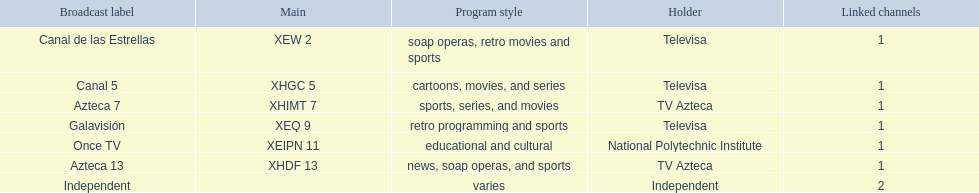What are each of the networks? Canal de las Estrellas, Canal 5, Azteca 7, Galavisión, Once TV, Azteca 13, Independent. Who owns them? Televisa, Televisa, TV Azteca, Televisa, National Polytechnic Institute, TV Azteca, Independent. Which networks aren't owned by televisa? Azteca 7, Once TV, Azteca 13, Independent. What type of programming do those networks offer? Sports, series, and movies, educational and cultural, news, soap operas, and sports, varies. And which network is the only one with sports? Azteca 7. 